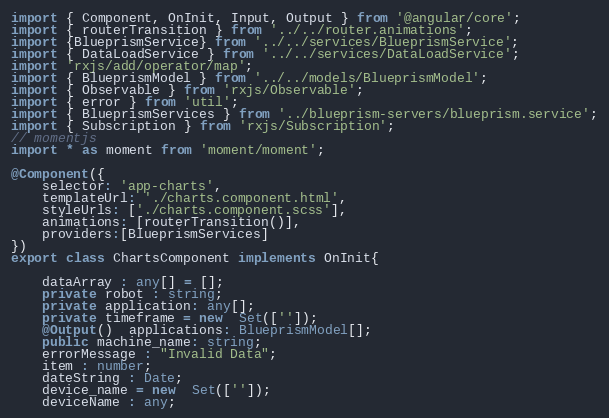<code> <loc_0><loc_0><loc_500><loc_500><_TypeScript_>import { Component, OnInit, Input, Output } from '@angular/core';
import { routerTransition } from '../../router.animations';
import {BlueprismService} from '../../services/BlueprismService';
import { DataLoadService } from '../../services/DataLoadService';
import 'rxjs/add/operator/map';
import { BlueprismModel } from '../../models/BlueprismModel';
import { Observable } from 'rxjs/Observable'; 
import { error } from 'util';
import { BlueprismServices } from '../blueprism-servers/blueprism.service';
import { Subscription } from 'rxjs/Subscription';
// momentjs
import * as moment from 'moment/moment';

@Component({
    selector: 'app-charts',
    templateUrl: './charts.component.html',
    styleUrls: ['./charts.component.scss'],
    animations: [routerTransition()],
    providers:[BlueprismServices]
})
export class ChartsComponent implements OnInit{
  
    dataArray : any[] = [];
    private robot : string;
    private application: any[];
    private timeframe = new  Set(['']); 
    @Output()  applications: BlueprismModel[]; 
    public machine_name: string;
    errorMessage : "Invalid Data";
    item : number;
    dateString : Date;
    device_name = new  Set(['']); 
    deviceName : any;</code> 